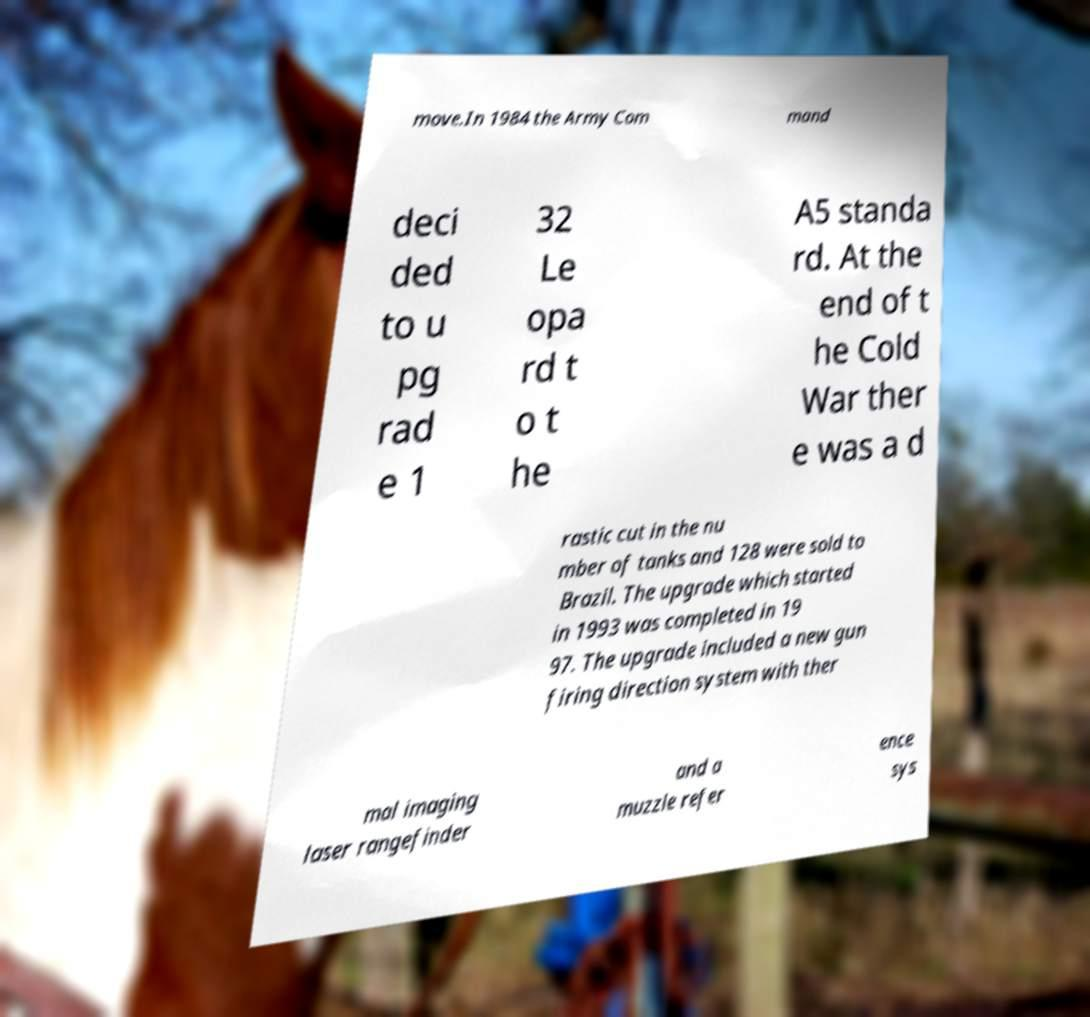For documentation purposes, I need the text within this image transcribed. Could you provide that? move.In 1984 the Army Com mand deci ded to u pg rad e 1 32 Le opa rd t o t he A5 standa rd. At the end of t he Cold War ther e was a d rastic cut in the nu mber of tanks and 128 were sold to Brazil. The upgrade which started in 1993 was completed in 19 97. The upgrade included a new gun firing direction system with ther mal imaging laser rangefinder and a muzzle refer ence sys 